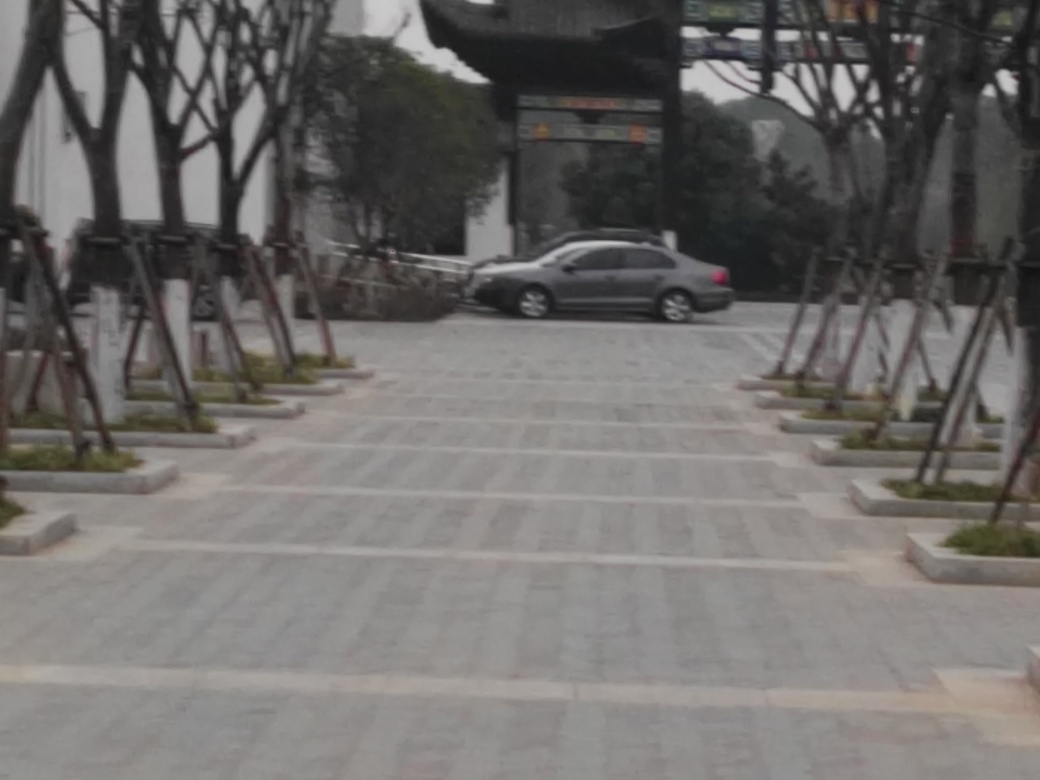Describe the atmosphere or mood conveyed by the image. The image conveys a quiet and tranquil mood, with no visible people and an empty car park, which implies a sense of solitude or calmness. 